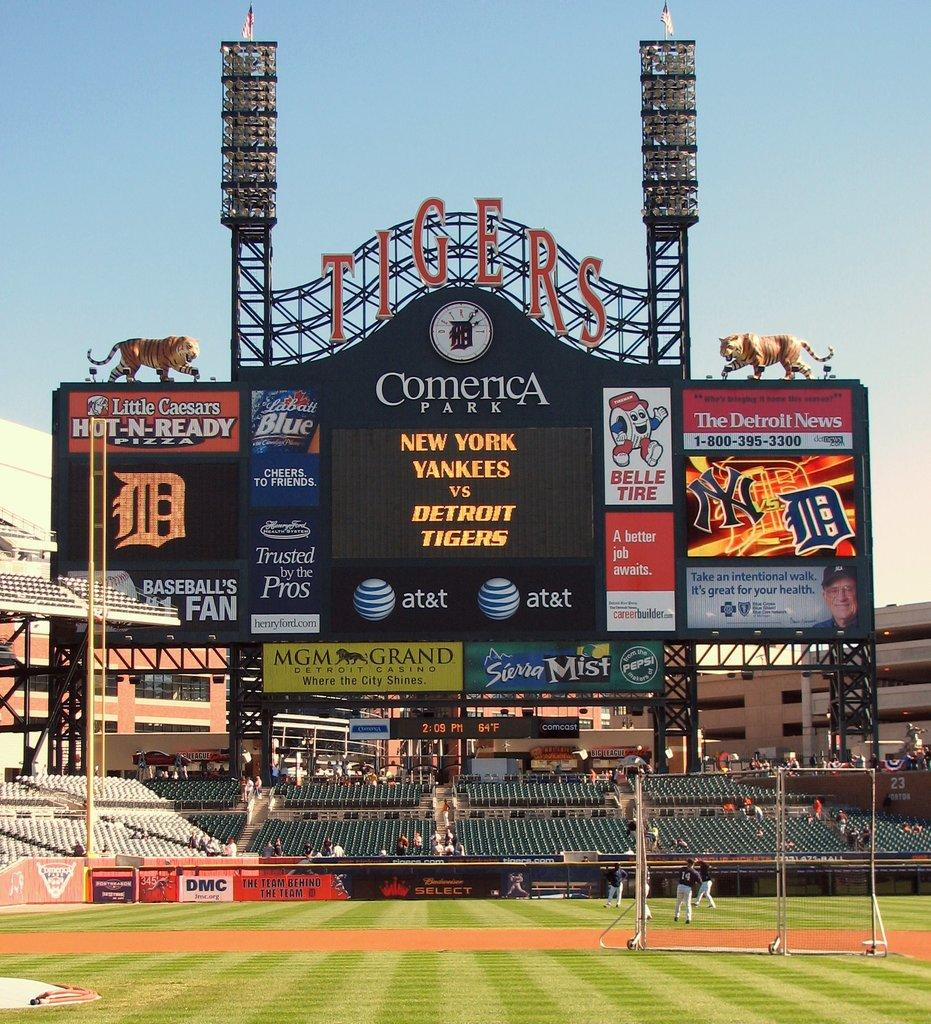<image>
Share a concise interpretation of the image provided. a Comerica Park scoreboard with teams on it 